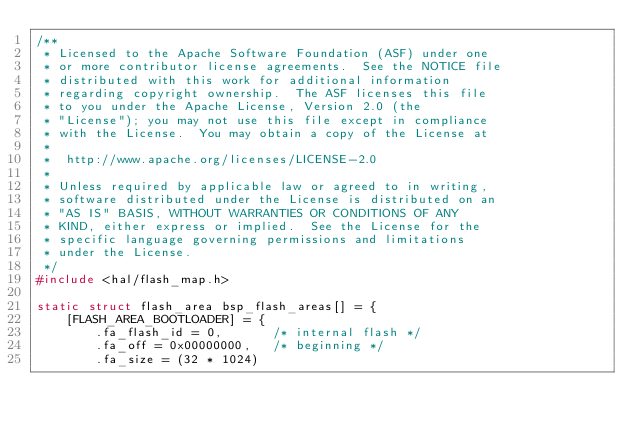Convert code to text. <code><loc_0><loc_0><loc_500><loc_500><_C_>/**
 * Licensed to the Apache Software Foundation (ASF) under one
 * or more contributor license agreements.  See the NOTICE file
 * distributed with this work for additional information
 * regarding copyright ownership.  The ASF licenses this file
 * to you under the Apache License, Version 2.0 (the
 * "License"); you may not use this file except in compliance
 * with the License.  You may obtain a copy of the License at
 * 
 *  http://www.apache.org/licenses/LICENSE-2.0
 *
 * Unless required by applicable law or agreed to in writing,
 * software distributed under the License is distributed on an
 * "AS IS" BASIS, WITHOUT WARRANTIES OR CONDITIONS OF ANY
 * KIND, either express or implied.  See the License for the
 * specific language governing permissions and limitations
 * under the License.
 */
#include <hal/flash_map.h>

static struct flash_area bsp_flash_areas[] = {
    [FLASH_AREA_BOOTLOADER] = {
        .fa_flash_id = 0,       /* internal flash */
        .fa_off = 0x00000000,   /* beginning */
        .fa_size = (32 * 1024)</code> 